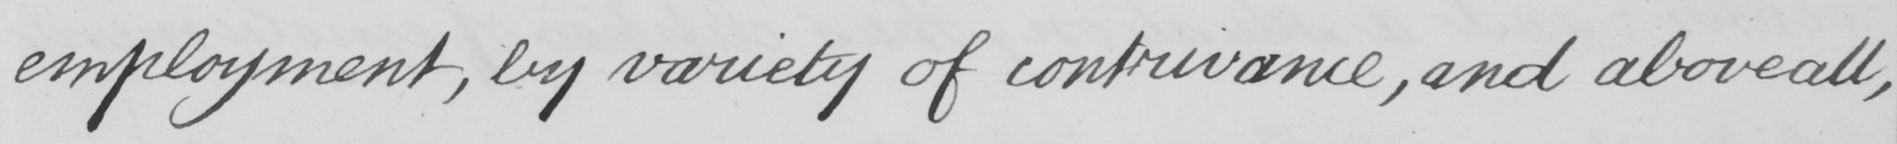Can you read and transcribe this handwriting? employment , by variety of contrivance , and above all , 